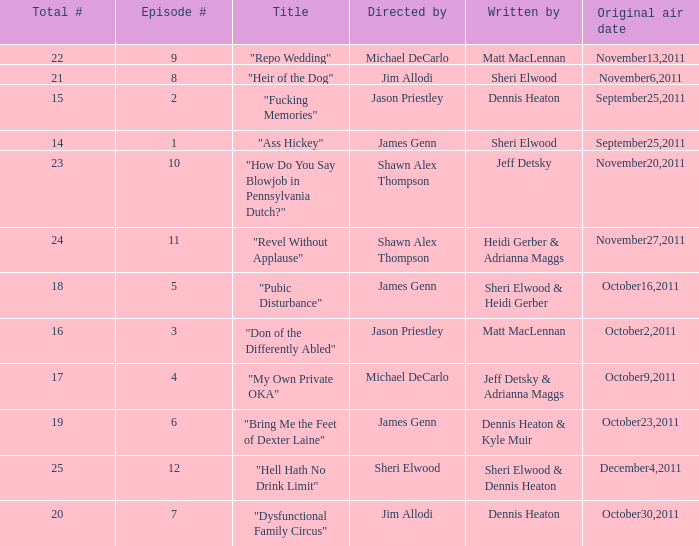How many different episode numbers are there for the episodes directed by Sheri Elwood? 1.0. 